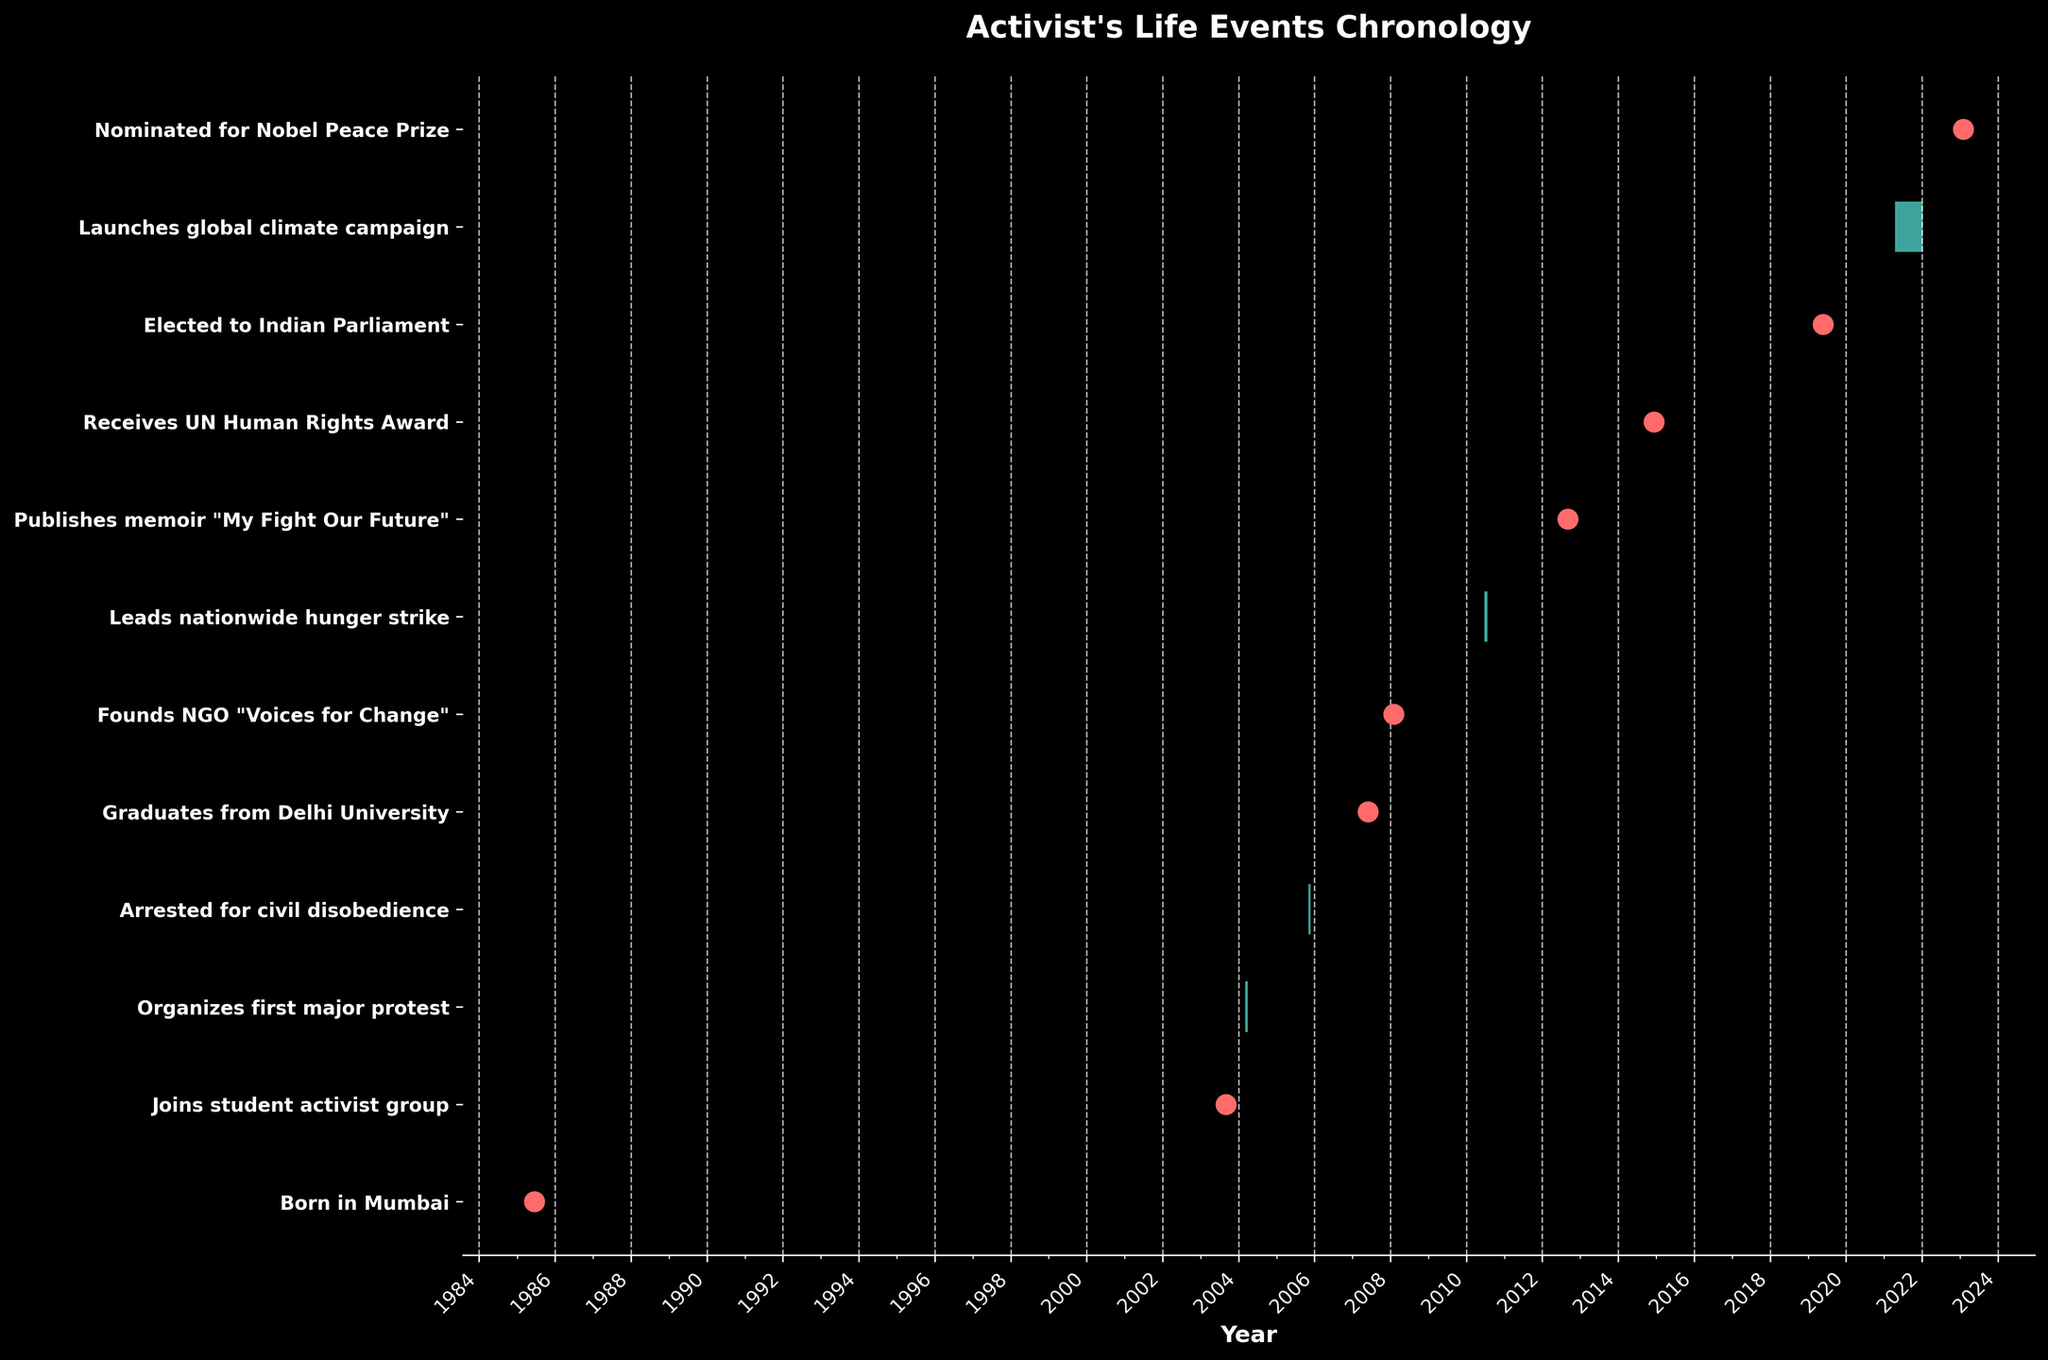How many events took place between 2005 and 2012, inclusive? First, identify the events that occurred between 2005 and 2012. They are: "Arrested for civil disobedience" (2005), "Graduates from Delhi University" (2007), "Founds NGO 'Voices for Change'" (2008), and "Publishes memoir 'My Fight Our Future'" (2012). Therefore, a total of 4 events are observed in this period.
Answer: 4 What event happened immediately after the activist was arrested for civil disobedience? The data shows "Arrested for civil disobedience" happened from 2005-11-10 to 2005-11-15. The next event is "Graduates from Delhi University" on 2007-05-30.
Answer: Graduates from Delhi University Which event had the longest duration in the Gantt Chart? Look at the length of all the bars in the chart. The event "Launches global climate campaign" has the longest bar, from 2021-04-22 to 2021-12-31, spanning 254 days.
Answer: Launches global climate campaign How many major life events are there in total? Count all the tasks listed on the y-axis in the Gantt Chart. There are 12 events in total.
Answer: 12 When did the activist lead the nationwide hunger strike, and how long did it last? Locate the event "Leads nationwide hunger strike" on the y-axis. It started on 2010-07-01 and ended on 2010-07-15, lasting for 15 days.
Answer: 2010-07-01 to 2010-07-15, 15 days Which event is represented by a scatter point (instead of a bar) and occurred in 2019? Look for scatter points that correspond with 2019 on the x-axis. The event is "Elected to Indian Parliament" on 2019-05-23.
Answer: Elected to Indian Parliament What are the events the activist undertook in the same year? Check if multiple events align vertically in the same year on the x-axis. There are no same-year multiple events on the chart, so the activist undertook distinct events each year.
Answer: None Was the activist's memoir published before or after receiving the UN Human Rights Award? Compare the dates for "Publishes memoir 'My Fight Our Future'" and "Receives UN Human Rights Award." The memoir was published on 2012-09-01, and the award was received on 2014-12-10, so the memoir was published before the award.
Answer: Before Between founding the NGO "Voices for Change" and leading the nationwide hunger strike, how many years did the activist wait? "Founds NGO 'Voices for Change'" happened on 2008-02-01, and "Leads nationwide hunger strike" on 2010-07-01. The gap is from February 2008 to July 2010, which is roughly 2 years and 5 months.
Answer: Approximately 2 years and 5 months 